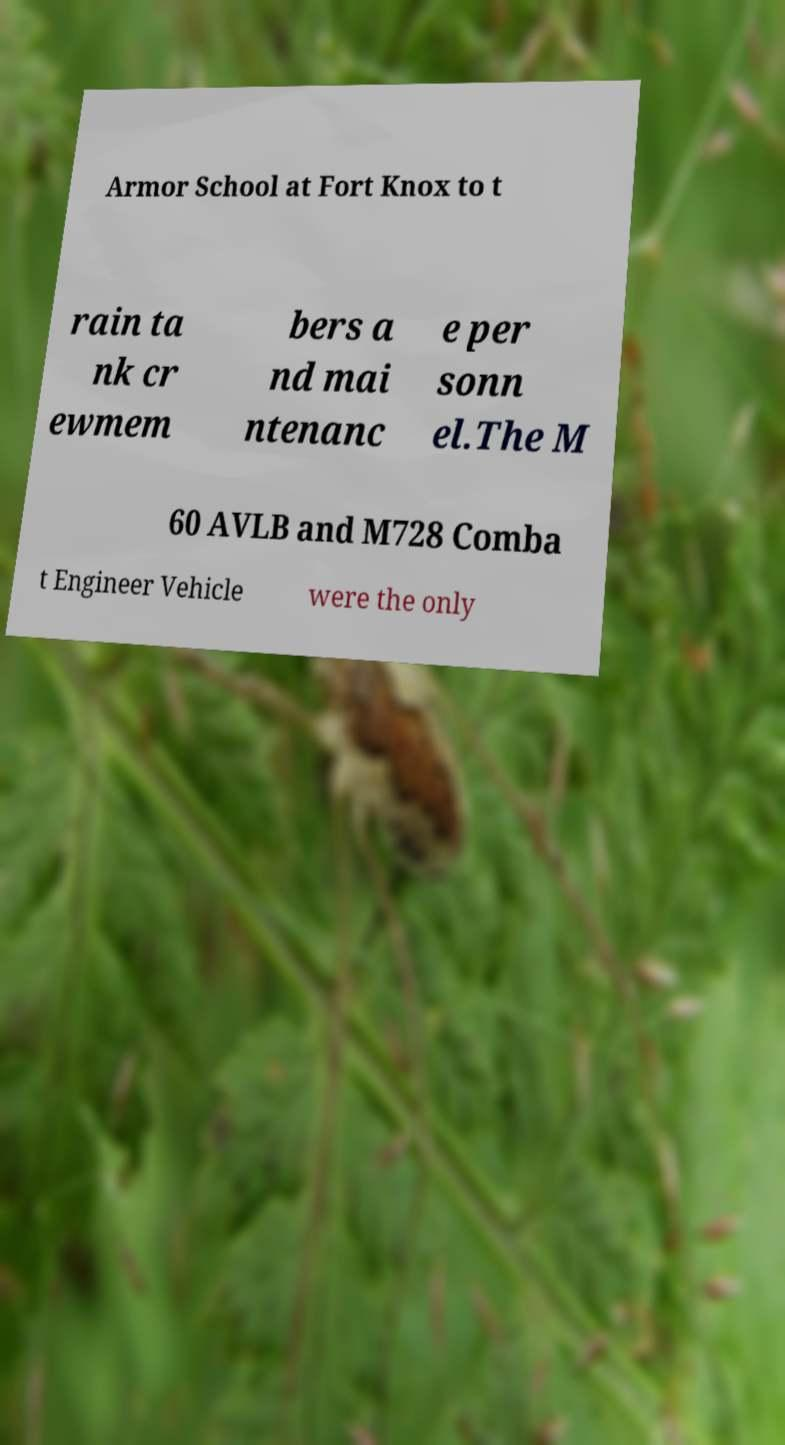Please identify and transcribe the text found in this image. Armor School at Fort Knox to t rain ta nk cr ewmem bers a nd mai ntenanc e per sonn el.The M 60 AVLB and M728 Comba t Engineer Vehicle were the only 